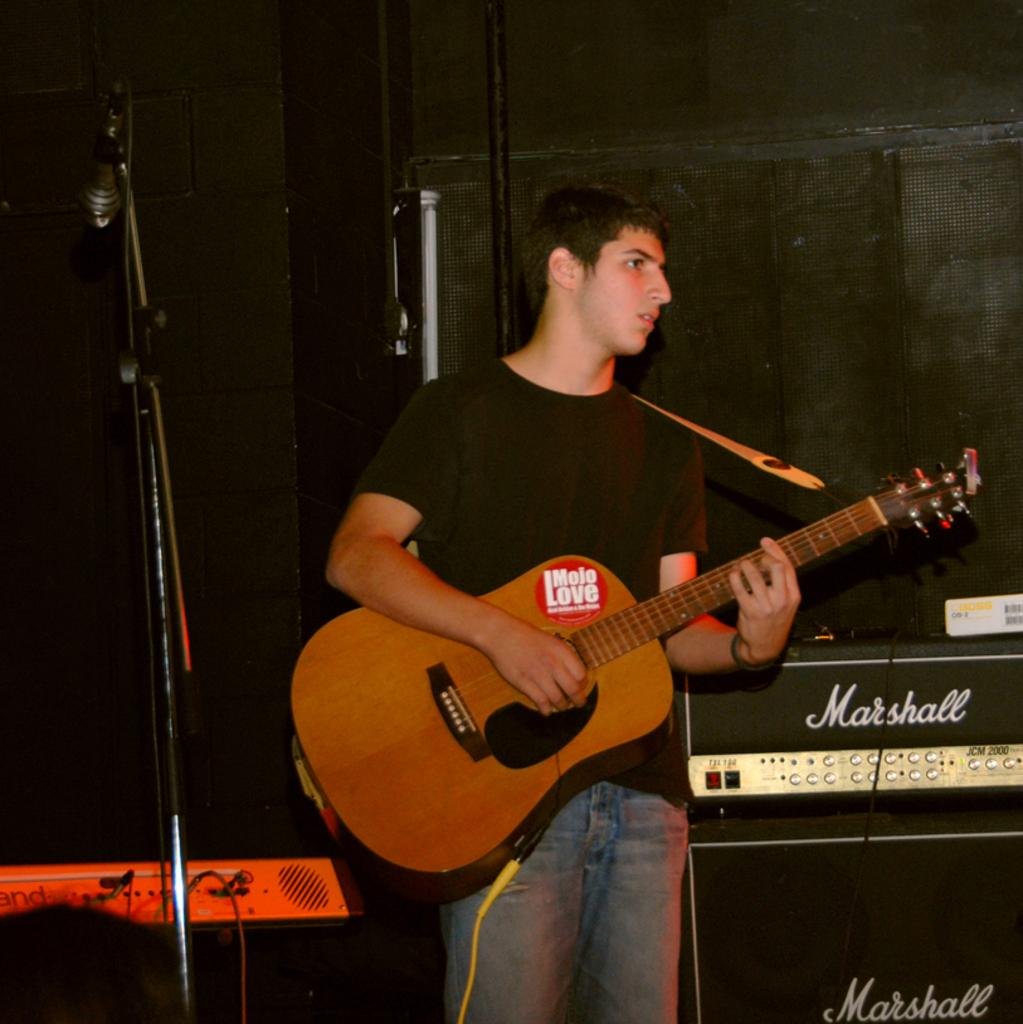Who is present in the image? There is a man in the image. What is the man doing in the image? The man is standing in the image. What object is the man holding in the image? The man is holding a guitar in the image. What other object can be seen in the image? There is a microphone in the image. What type of sign can be seen in the background of the image? There is no sign present in the image. Is there a volcano visible in the image? No, there is no volcano present in the image. 